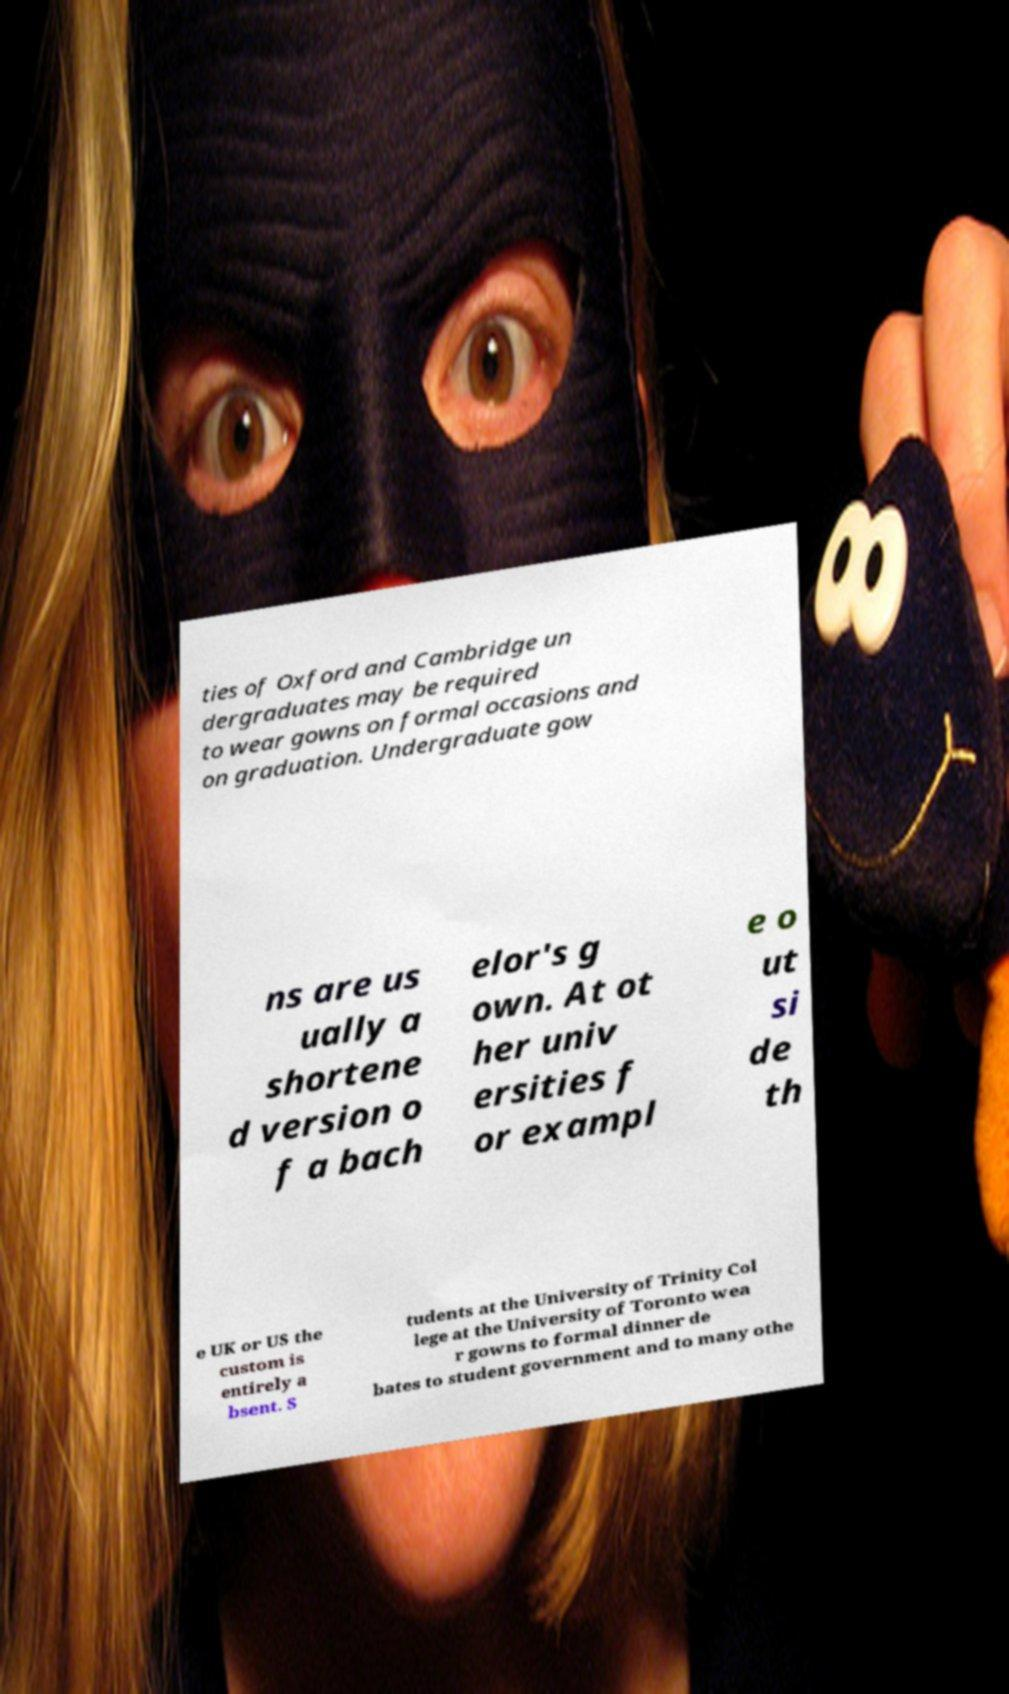Could you extract and type out the text from this image? ties of Oxford and Cambridge un dergraduates may be required to wear gowns on formal occasions and on graduation. Undergraduate gow ns are us ually a shortene d version o f a bach elor's g own. At ot her univ ersities f or exampl e o ut si de th e UK or US the custom is entirely a bsent. S tudents at the University of Trinity Col lege at the University of Toronto wea r gowns to formal dinner de bates to student government and to many othe 